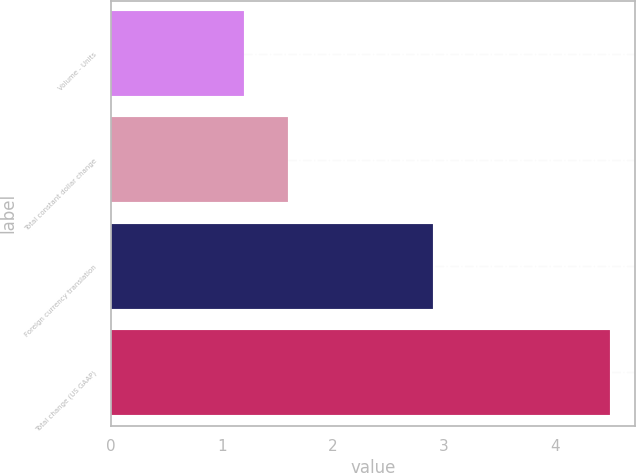<chart> <loc_0><loc_0><loc_500><loc_500><bar_chart><fcel>Volume - Units<fcel>Total constant dollar change<fcel>Foreign currency translation<fcel>Total change (US GAAP)<nl><fcel>1.2<fcel>1.6<fcel>2.9<fcel>4.5<nl></chart> 